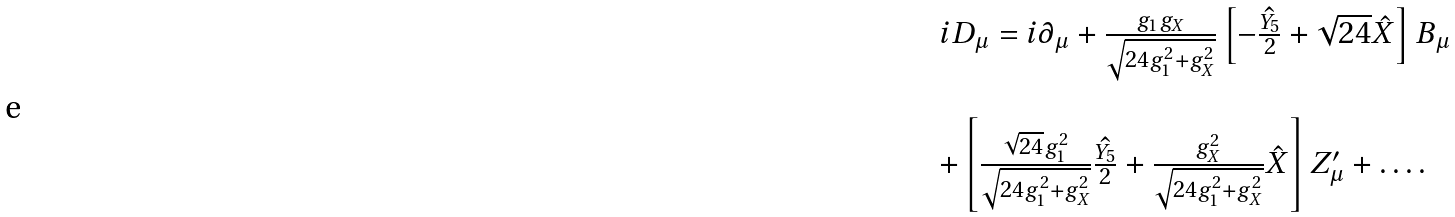<formula> <loc_0><loc_0><loc_500><loc_500>\begin{array} { l } i D _ { \mu } = i \partial _ { \mu } + \frac { g _ { 1 } g _ { X } } { \sqrt { 2 4 g _ { 1 } ^ { 2 } + g _ { X } ^ { 2 } } } \left [ - \hat { \frac { Y _ { 5 } } { 2 } } + \sqrt { 2 4 } \hat { X } \right ] B _ { \mu } \\ \\ + \left [ \frac { \sqrt { 2 4 } g _ { 1 } ^ { 2 } } { \sqrt { 2 4 g _ { 1 } ^ { 2 } + g _ { X } ^ { 2 } } } \hat { \frac { Y _ { 5 } } { 2 } } + \frac { g _ { X } ^ { 2 } } { \sqrt { 2 4 g _ { 1 } ^ { 2 } + g _ { X } ^ { 2 } } } \hat { X } \right ] Z ^ { \prime } _ { \mu } + \dots . \end{array}</formula> 